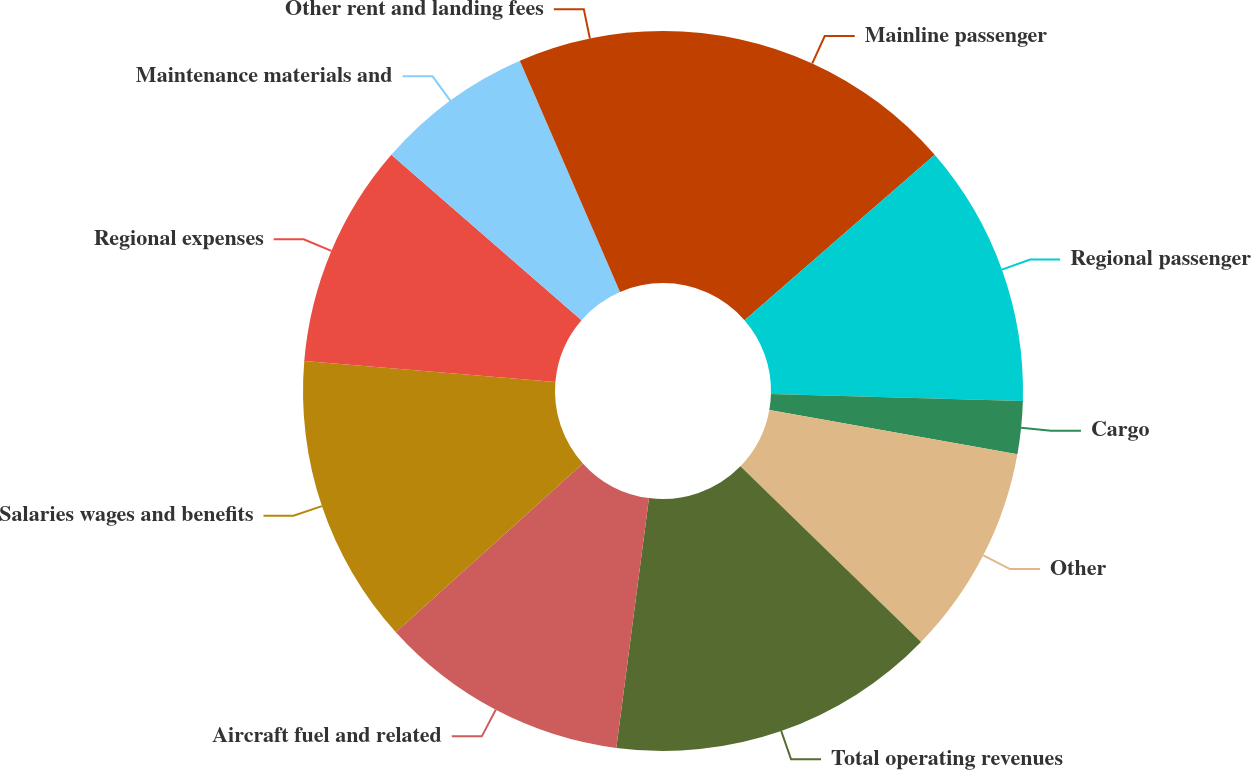<chart> <loc_0><loc_0><loc_500><loc_500><pie_chart><fcel>Mainline passenger<fcel>Regional passenger<fcel>Cargo<fcel>Other<fcel>Total operating revenues<fcel>Aircraft fuel and related<fcel>Salaries wages and benefits<fcel>Regional expenses<fcel>Maintenance materials and<fcel>Other rent and landing fees<nl><fcel>13.61%<fcel>11.83%<fcel>2.37%<fcel>9.47%<fcel>14.79%<fcel>11.24%<fcel>13.02%<fcel>10.06%<fcel>7.1%<fcel>6.51%<nl></chart> 